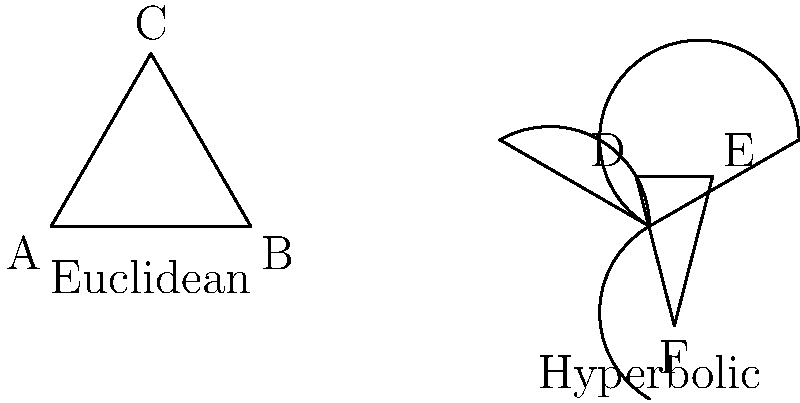In Non-Euclidean Geometry, how does the sum of interior angles in a hyperbolic triangle compare to that of a Euclidean triangle? Relate this concept to the curvature of space in aviation, considering the differences between helicopter and commercial airplane navigation. 1. Euclidean Geometry:
   - In a flat plane (Euclidean geometry), the sum of interior angles of a triangle is always 180°.
   - This is represented by triangle ABC in the left diagram.

2. Hyperbolic Geometry:
   - In a hyperbolic plane, the sum of interior angles of a triangle is always less than 180°.
   - This is represented by triangle DEF in the right diagram.

3. Angle Deficit:
   - The difference between 180° and the sum of angles in a hyperbolic triangle is called the angle deficit.
   - The angle deficit is proportional to the area of the triangle in hyperbolic space.

4. Relation to Aviation:
   - In aviation, the Earth's surface approximates a sphere, which is closer to hyperbolic geometry than Euclidean.
   - For short distances, pilots (both helicopter and commercial airplane) can use flat Earth approximations (Euclidean).
   - For longer distances, especially for commercial airplanes, the curvature of the Earth becomes significant.

5. Helicopter vs. Commercial Airplane Navigation:
   - Helicopters typically fly shorter distances and at lower altitudes, where Euclidean approximations are often sufficient.
   - Commercial airplanes fly longer distances and at higher altitudes, where the Earth's curvature becomes more relevant.
   - Long-distance flights use great circle routes, which are the shortest path between two points on a sphere, analogous to "straight lines" in hyperbolic space.

6. Impact on Navigation:
   - Understanding non-Euclidean geometry is crucial for accurate long-distance navigation in commercial aviation.
   - It affects fuel calculations, flight time estimates, and optimal route planning.
   - Military applications, such as intercontinental ballistic missile trajectories, also rely heavily on non-Euclidean geometric principles.
Answer: The sum of interior angles in a hyperbolic triangle is less than 180°, unlike 180° in Euclidean geometry. This relates to Earth's curvature in aviation, more significant for long-distance commercial flights than short-range helicopter operations. 